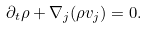Convert formula to latex. <formula><loc_0><loc_0><loc_500><loc_500>\partial _ { t } \rho + \nabla _ { j } ( \rho v _ { j } ) = 0 .</formula> 